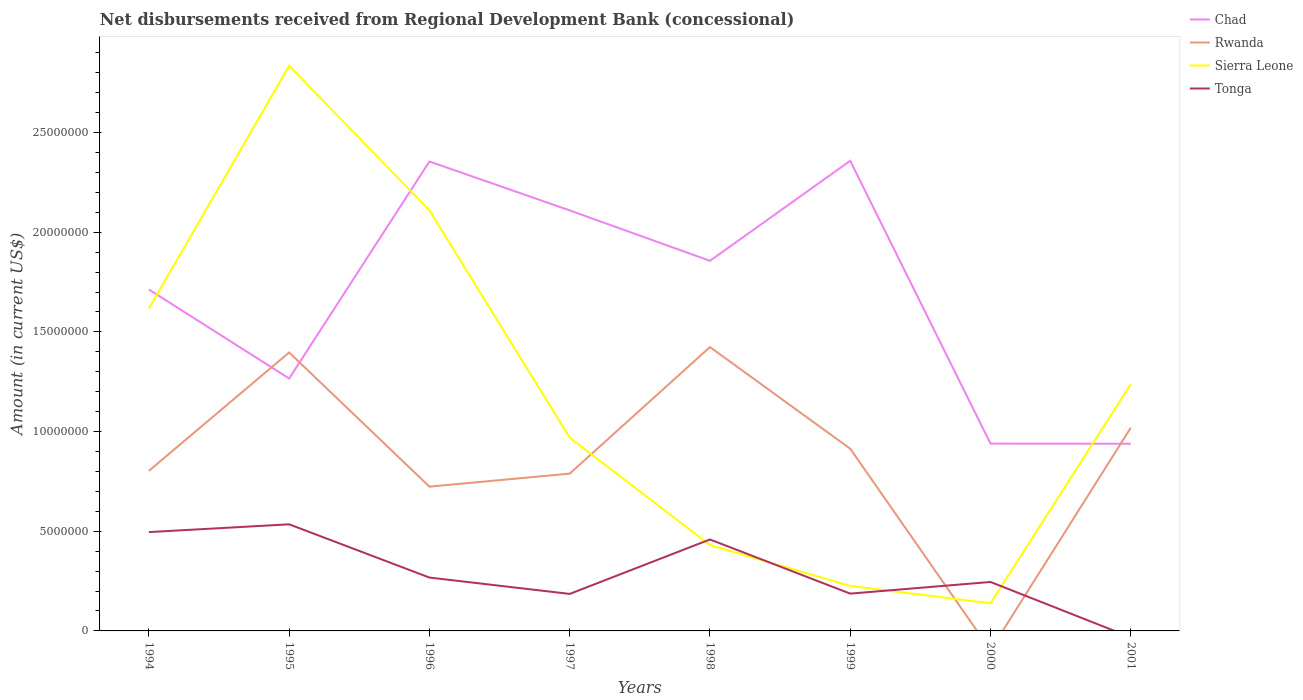How many different coloured lines are there?
Give a very brief answer. 4. What is the total amount of disbursements received from Regional Development Bank in Tonga in the graph?
Offer a very short reply. 2.13e+06. What is the difference between the highest and the second highest amount of disbursements received from Regional Development Bank in Chad?
Give a very brief answer. 1.42e+07. What is the difference between the highest and the lowest amount of disbursements received from Regional Development Bank in Sierra Leone?
Ensure brevity in your answer.  4. Is the amount of disbursements received from Regional Development Bank in Chad strictly greater than the amount of disbursements received from Regional Development Bank in Sierra Leone over the years?
Provide a succinct answer. No. How many lines are there?
Offer a terse response. 4. Does the graph contain any zero values?
Your answer should be compact. Yes. Where does the legend appear in the graph?
Ensure brevity in your answer.  Top right. How many legend labels are there?
Your answer should be compact. 4. What is the title of the graph?
Offer a very short reply. Net disbursements received from Regional Development Bank (concessional). What is the Amount (in current US$) in Chad in 1994?
Give a very brief answer. 1.71e+07. What is the Amount (in current US$) in Rwanda in 1994?
Your answer should be compact. 8.03e+06. What is the Amount (in current US$) in Sierra Leone in 1994?
Your answer should be very brief. 1.62e+07. What is the Amount (in current US$) in Tonga in 1994?
Offer a terse response. 4.96e+06. What is the Amount (in current US$) in Chad in 1995?
Give a very brief answer. 1.27e+07. What is the Amount (in current US$) of Rwanda in 1995?
Give a very brief answer. 1.40e+07. What is the Amount (in current US$) in Sierra Leone in 1995?
Give a very brief answer. 2.83e+07. What is the Amount (in current US$) in Tonga in 1995?
Offer a very short reply. 5.35e+06. What is the Amount (in current US$) in Chad in 1996?
Offer a very short reply. 2.35e+07. What is the Amount (in current US$) in Rwanda in 1996?
Your response must be concise. 7.24e+06. What is the Amount (in current US$) in Sierra Leone in 1996?
Your answer should be very brief. 2.11e+07. What is the Amount (in current US$) of Tonga in 1996?
Provide a short and direct response. 2.68e+06. What is the Amount (in current US$) in Chad in 1997?
Give a very brief answer. 2.11e+07. What is the Amount (in current US$) in Rwanda in 1997?
Provide a short and direct response. 7.89e+06. What is the Amount (in current US$) of Sierra Leone in 1997?
Your response must be concise. 9.70e+06. What is the Amount (in current US$) in Tonga in 1997?
Give a very brief answer. 1.86e+06. What is the Amount (in current US$) of Chad in 1998?
Give a very brief answer. 1.86e+07. What is the Amount (in current US$) of Rwanda in 1998?
Keep it short and to the point. 1.42e+07. What is the Amount (in current US$) of Sierra Leone in 1998?
Offer a terse response. 4.31e+06. What is the Amount (in current US$) of Tonga in 1998?
Your answer should be compact. 4.59e+06. What is the Amount (in current US$) in Chad in 1999?
Provide a short and direct response. 2.36e+07. What is the Amount (in current US$) in Rwanda in 1999?
Provide a short and direct response. 9.14e+06. What is the Amount (in current US$) of Sierra Leone in 1999?
Your response must be concise. 2.26e+06. What is the Amount (in current US$) in Tonga in 1999?
Ensure brevity in your answer.  1.87e+06. What is the Amount (in current US$) of Chad in 2000?
Provide a short and direct response. 9.40e+06. What is the Amount (in current US$) of Sierra Leone in 2000?
Your response must be concise. 1.39e+06. What is the Amount (in current US$) of Tonga in 2000?
Provide a short and direct response. 2.46e+06. What is the Amount (in current US$) in Chad in 2001?
Your answer should be compact. 9.39e+06. What is the Amount (in current US$) of Rwanda in 2001?
Your answer should be compact. 1.02e+07. What is the Amount (in current US$) of Sierra Leone in 2001?
Your answer should be compact. 1.24e+07. What is the Amount (in current US$) in Tonga in 2001?
Ensure brevity in your answer.  0. Across all years, what is the maximum Amount (in current US$) in Chad?
Provide a short and direct response. 2.36e+07. Across all years, what is the maximum Amount (in current US$) in Rwanda?
Your answer should be very brief. 1.42e+07. Across all years, what is the maximum Amount (in current US$) of Sierra Leone?
Offer a terse response. 2.83e+07. Across all years, what is the maximum Amount (in current US$) in Tonga?
Offer a very short reply. 5.35e+06. Across all years, what is the minimum Amount (in current US$) of Chad?
Give a very brief answer. 9.39e+06. Across all years, what is the minimum Amount (in current US$) in Rwanda?
Keep it short and to the point. 0. Across all years, what is the minimum Amount (in current US$) of Sierra Leone?
Make the answer very short. 1.39e+06. Across all years, what is the minimum Amount (in current US$) of Tonga?
Provide a short and direct response. 0. What is the total Amount (in current US$) in Chad in the graph?
Offer a terse response. 1.35e+08. What is the total Amount (in current US$) of Rwanda in the graph?
Give a very brief answer. 7.07e+07. What is the total Amount (in current US$) in Sierra Leone in the graph?
Offer a very short reply. 9.56e+07. What is the total Amount (in current US$) of Tonga in the graph?
Offer a very short reply. 2.38e+07. What is the difference between the Amount (in current US$) in Chad in 1994 and that in 1995?
Your response must be concise. 4.47e+06. What is the difference between the Amount (in current US$) of Rwanda in 1994 and that in 1995?
Give a very brief answer. -5.94e+06. What is the difference between the Amount (in current US$) in Sierra Leone in 1994 and that in 1995?
Ensure brevity in your answer.  -1.22e+07. What is the difference between the Amount (in current US$) of Tonga in 1994 and that in 1995?
Your response must be concise. -3.90e+05. What is the difference between the Amount (in current US$) of Chad in 1994 and that in 1996?
Your response must be concise. -6.42e+06. What is the difference between the Amount (in current US$) of Rwanda in 1994 and that in 1996?
Give a very brief answer. 7.94e+05. What is the difference between the Amount (in current US$) of Sierra Leone in 1994 and that in 1996?
Keep it short and to the point. -4.92e+06. What is the difference between the Amount (in current US$) in Tonga in 1994 and that in 1996?
Your answer should be compact. 2.28e+06. What is the difference between the Amount (in current US$) of Chad in 1994 and that in 1997?
Keep it short and to the point. -3.97e+06. What is the difference between the Amount (in current US$) in Rwanda in 1994 and that in 1997?
Your answer should be compact. 1.41e+05. What is the difference between the Amount (in current US$) of Sierra Leone in 1994 and that in 1997?
Offer a very short reply. 6.48e+06. What is the difference between the Amount (in current US$) of Tonga in 1994 and that in 1997?
Your answer should be compact. 3.10e+06. What is the difference between the Amount (in current US$) of Chad in 1994 and that in 1998?
Your answer should be compact. -1.44e+06. What is the difference between the Amount (in current US$) in Rwanda in 1994 and that in 1998?
Provide a short and direct response. -6.21e+06. What is the difference between the Amount (in current US$) in Sierra Leone in 1994 and that in 1998?
Keep it short and to the point. 1.19e+07. What is the difference between the Amount (in current US$) in Tonga in 1994 and that in 1998?
Ensure brevity in your answer.  3.70e+05. What is the difference between the Amount (in current US$) in Chad in 1994 and that in 1999?
Keep it short and to the point. -6.46e+06. What is the difference between the Amount (in current US$) in Rwanda in 1994 and that in 1999?
Your answer should be compact. -1.11e+06. What is the difference between the Amount (in current US$) of Sierra Leone in 1994 and that in 1999?
Your answer should be compact. 1.39e+07. What is the difference between the Amount (in current US$) in Tonga in 1994 and that in 1999?
Provide a succinct answer. 3.09e+06. What is the difference between the Amount (in current US$) of Chad in 1994 and that in 2000?
Provide a short and direct response. 7.73e+06. What is the difference between the Amount (in current US$) in Sierra Leone in 1994 and that in 2000?
Give a very brief answer. 1.48e+07. What is the difference between the Amount (in current US$) of Tonga in 1994 and that in 2000?
Provide a succinct answer. 2.50e+06. What is the difference between the Amount (in current US$) in Chad in 1994 and that in 2001?
Your response must be concise. 7.74e+06. What is the difference between the Amount (in current US$) in Rwanda in 1994 and that in 2001?
Your answer should be very brief. -2.16e+06. What is the difference between the Amount (in current US$) in Sierra Leone in 1994 and that in 2001?
Offer a very short reply. 3.80e+06. What is the difference between the Amount (in current US$) of Chad in 1995 and that in 1996?
Offer a terse response. -1.09e+07. What is the difference between the Amount (in current US$) of Rwanda in 1995 and that in 1996?
Keep it short and to the point. 6.73e+06. What is the difference between the Amount (in current US$) of Sierra Leone in 1995 and that in 1996?
Your answer should be compact. 7.25e+06. What is the difference between the Amount (in current US$) of Tonga in 1995 and that in 1996?
Your answer should be very brief. 2.67e+06. What is the difference between the Amount (in current US$) in Chad in 1995 and that in 1997?
Offer a terse response. -8.43e+06. What is the difference between the Amount (in current US$) in Rwanda in 1995 and that in 1997?
Ensure brevity in your answer.  6.08e+06. What is the difference between the Amount (in current US$) of Sierra Leone in 1995 and that in 1997?
Give a very brief answer. 1.87e+07. What is the difference between the Amount (in current US$) in Tonga in 1995 and that in 1997?
Your answer should be compact. 3.49e+06. What is the difference between the Amount (in current US$) in Chad in 1995 and that in 1998?
Make the answer very short. -5.90e+06. What is the difference between the Amount (in current US$) in Sierra Leone in 1995 and that in 1998?
Your answer should be very brief. 2.40e+07. What is the difference between the Amount (in current US$) of Tonga in 1995 and that in 1998?
Your answer should be compact. 7.60e+05. What is the difference between the Amount (in current US$) in Chad in 1995 and that in 1999?
Give a very brief answer. -1.09e+07. What is the difference between the Amount (in current US$) in Rwanda in 1995 and that in 1999?
Make the answer very short. 4.83e+06. What is the difference between the Amount (in current US$) of Sierra Leone in 1995 and that in 1999?
Give a very brief answer. 2.61e+07. What is the difference between the Amount (in current US$) in Tonga in 1995 and that in 1999?
Provide a succinct answer. 3.48e+06. What is the difference between the Amount (in current US$) of Chad in 1995 and that in 2000?
Offer a terse response. 3.26e+06. What is the difference between the Amount (in current US$) of Sierra Leone in 1995 and that in 2000?
Make the answer very short. 2.70e+07. What is the difference between the Amount (in current US$) of Tonga in 1995 and that in 2000?
Your answer should be compact. 2.89e+06. What is the difference between the Amount (in current US$) in Chad in 1995 and that in 2001?
Your answer should be compact. 3.27e+06. What is the difference between the Amount (in current US$) of Rwanda in 1995 and that in 2001?
Your response must be concise. 3.78e+06. What is the difference between the Amount (in current US$) of Sierra Leone in 1995 and that in 2001?
Your response must be concise. 1.60e+07. What is the difference between the Amount (in current US$) of Chad in 1996 and that in 1997?
Keep it short and to the point. 2.45e+06. What is the difference between the Amount (in current US$) in Rwanda in 1996 and that in 1997?
Provide a short and direct response. -6.53e+05. What is the difference between the Amount (in current US$) in Sierra Leone in 1996 and that in 1997?
Offer a terse response. 1.14e+07. What is the difference between the Amount (in current US$) of Tonga in 1996 and that in 1997?
Ensure brevity in your answer.  8.21e+05. What is the difference between the Amount (in current US$) of Chad in 1996 and that in 1998?
Provide a short and direct response. 4.98e+06. What is the difference between the Amount (in current US$) in Rwanda in 1996 and that in 1998?
Offer a very short reply. -7.00e+06. What is the difference between the Amount (in current US$) in Sierra Leone in 1996 and that in 1998?
Offer a terse response. 1.68e+07. What is the difference between the Amount (in current US$) in Tonga in 1996 and that in 1998?
Provide a short and direct response. -1.91e+06. What is the difference between the Amount (in current US$) in Chad in 1996 and that in 1999?
Make the answer very short. -3.50e+04. What is the difference between the Amount (in current US$) in Rwanda in 1996 and that in 1999?
Offer a terse response. -1.90e+06. What is the difference between the Amount (in current US$) of Sierra Leone in 1996 and that in 1999?
Make the answer very short. 1.88e+07. What is the difference between the Amount (in current US$) in Tonga in 1996 and that in 1999?
Your response must be concise. 8.06e+05. What is the difference between the Amount (in current US$) in Chad in 1996 and that in 2000?
Make the answer very short. 1.42e+07. What is the difference between the Amount (in current US$) in Sierra Leone in 1996 and that in 2000?
Ensure brevity in your answer.  1.97e+07. What is the difference between the Amount (in current US$) in Tonga in 1996 and that in 2000?
Ensure brevity in your answer.  2.21e+05. What is the difference between the Amount (in current US$) in Chad in 1996 and that in 2001?
Your answer should be very brief. 1.42e+07. What is the difference between the Amount (in current US$) in Rwanda in 1996 and that in 2001?
Your answer should be very brief. -2.95e+06. What is the difference between the Amount (in current US$) in Sierra Leone in 1996 and that in 2001?
Provide a short and direct response. 8.72e+06. What is the difference between the Amount (in current US$) of Chad in 1997 and that in 1998?
Your response must be concise. 2.53e+06. What is the difference between the Amount (in current US$) of Rwanda in 1997 and that in 1998?
Make the answer very short. -6.35e+06. What is the difference between the Amount (in current US$) of Sierra Leone in 1997 and that in 1998?
Make the answer very short. 5.39e+06. What is the difference between the Amount (in current US$) of Tonga in 1997 and that in 1998?
Provide a succinct answer. -2.73e+06. What is the difference between the Amount (in current US$) of Chad in 1997 and that in 1999?
Keep it short and to the point. -2.49e+06. What is the difference between the Amount (in current US$) in Rwanda in 1997 and that in 1999?
Your response must be concise. -1.25e+06. What is the difference between the Amount (in current US$) in Sierra Leone in 1997 and that in 1999?
Provide a succinct answer. 7.44e+06. What is the difference between the Amount (in current US$) of Tonga in 1997 and that in 1999?
Provide a succinct answer. -1.50e+04. What is the difference between the Amount (in current US$) in Chad in 1997 and that in 2000?
Give a very brief answer. 1.17e+07. What is the difference between the Amount (in current US$) in Sierra Leone in 1997 and that in 2000?
Give a very brief answer. 8.31e+06. What is the difference between the Amount (in current US$) in Tonga in 1997 and that in 2000?
Give a very brief answer. -6.00e+05. What is the difference between the Amount (in current US$) of Chad in 1997 and that in 2001?
Provide a succinct answer. 1.17e+07. What is the difference between the Amount (in current US$) of Rwanda in 1997 and that in 2001?
Provide a succinct answer. -2.30e+06. What is the difference between the Amount (in current US$) in Sierra Leone in 1997 and that in 2001?
Your answer should be very brief. -2.68e+06. What is the difference between the Amount (in current US$) of Chad in 1998 and that in 1999?
Ensure brevity in your answer.  -5.02e+06. What is the difference between the Amount (in current US$) in Rwanda in 1998 and that in 1999?
Your answer should be compact. 5.10e+06. What is the difference between the Amount (in current US$) in Sierra Leone in 1998 and that in 1999?
Offer a very short reply. 2.05e+06. What is the difference between the Amount (in current US$) of Tonga in 1998 and that in 1999?
Make the answer very short. 2.72e+06. What is the difference between the Amount (in current US$) of Chad in 1998 and that in 2000?
Provide a short and direct response. 9.17e+06. What is the difference between the Amount (in current US$) of Sierra Leone in 1998 and that in 2000?
Make the answer very short. 2.92e+06. What is the difference between the Amount (in current US$) in Tonga in 1998 and that in 2000?
Ensure brevity in your answer.  2.13e+06. What is the difference between the Amount (in current US$) of Chad in 1998 and that in 2001?
Your response must be concise. 9.18e+06. What is the difference between the Amount (in current US$) in Rwanda in 1998 and that in 2001?
Make the answer very short. 4.05e+06. What is the difference between the Amount (in current US$) of Sierra Leone in 1998 and that in 2001?
Provide a short and direct response. -8.07e+06. What is the difference between the Amount (in current US$) of Chad in 1999 and that in 2000?
Provide a short and direct response. 1.42e+07. What is the difference between the Amount (in current US$) of Sierra Leone in 1999 and that in 2000?
Give a very brief answer. 8.71e+05. What is the difference between the Amount (in current US$) of Tonga in 1999 and that in 2000?
Offer a very short reply. -5.85e+05. What is the difference between the Amount (in current US$) of Chad in 1999 and that in 2001?
Your answer should be very brief. 1.42e+07. What is the difference between the Amount (in current US$) in Rwanda in 1999 and that in 2001?
Provide a succinct answer. -1.05e+06. What is the difference between the Amount (in current US$) of Sierra Leone in 1999 and that in 2001?
Make the answer very short. -1.01e+07. What is the difference between the Amount (in current US$) in Chad in 2000 and that in 2001?
Your answer should be compact. 8000. What is the difference between the Amount (in current US$) of Sierra Leone in 2000 and that in 2001?
Offer a terse response. -1.10e+07. What is the difference between the Amount (in current US$) in Chad in 1994 and the Amount (in current US$) in Rwanda in 1995?
Your response must be concise. 3.16e+06. What is the difference between the Amount (in current US$) of Chad in 1994 and the Amount (in current US$) of Sierra Leone in 1995?
Offer a terse response. -1.12e+07. What is the difference between the Amount (in current US$) in Chad in 1994 and the Amount (in current US$) in Tonga in 1995?
Ensure brevity in your answer.  1.18e+07. What is the difference between the Amount (in current US$) in Rwanda in 1994 and the Amount (in current US$) in Sierra Leone in 1995?
Offer a very short reply. -2.03e+07. What is the difference between the Amount (in current US$) of Rwanda in 1994 and the Amount (in current US$) of Tonga in 1995?
Offer a terse response. 2.68e+06. What is the difference between the Amount (in current US$) in Sierra Leone in 1994 and the Amount (in current US$) in Tonga in 1995?
Keep it short and to the point. 1.08e+07. What is the difference between the Amount (in current US$) in Chad in 1994 and the Amount (in current US$) in Rwanda in 1996?
Ensure brevity in your answer.  9.89e+06. What is the difference between the Amount (in current US$) in Chad in 1994 and the Amount (in current US$) in Sierra Leone in 1996?
Offer a very short reply. -3.97e+06. What is the difference between the Amount (in current US$) of Chad in 1994 and the Amount (in current US$) of Tonga in 1996?
Keep it short and to the point. 1.44e+07. What is the difference between the Amount (in current US$) of Rwanda in 1994 and the Amount (in current US$) of Sierra Leone in 1996?
Offer a terse response. -1.31e+07. What is the difference between the Amount (in current US$) in Rwanda in 1994 and the Amount (in current US$) in Tonga in 1996?
Provide a succinct answer. 5.35e+06. What is the difference between the Amount (in current US$) of Sierra Leone in 1994 and the Amount (in current US$) of Tonga in 1996?
Provide a succinct answer. 1.35e+07. What is the difference between the Amount (in current US$) of Chad in 1994 and the Amount (in current US$) of Rwanda in 1997?
Give a very brief answer. 9.24e+06. What is the difference between the Amount (in current US$) of Chad in 1994 and the Amount (in current US$) of Sierra Leone in 1997?
Provide a short and direct response. 7.43e+06. What is the difference between the Amount (in current US$) of Chad in 1994 and the Amount (in current US$) of Tonga in 1997?
Offer a terse response. 1.53e+07. What is the difference between the Amount (in current US$) in Rwanda in 1994 and the Amount (in current US$) in Sierra Leone in 1997?
Ensure brevity in your answer.  -1.66e+06. What is the difference between the Amount (in current US$) of Rwanda in 1994 and the Amount (in current US$) of Tonga in 1997?
Offer a terse response. 6.18e+06. What is the difference between the Amount (in current US$) in Sierra Leone in 1994 and the Amount (in current US$) in Tonga in 1997?
Ensure brevity in your answer.  1.43e+07. What is the difference between the Amount (in current US$) of Chad in 1994 and the Amount (in current US$) of Rwanda in 1998?
Provide a short and direct response. 2.89e+06. What is the difference between the Amount (in current US$) of Chad in 1994 and the Amount (in current US$) of Sierra Leone in 1998?
Your answer should be compact. 1.28e+07. What is the difference between the Amount (in current US$) in Chad in 1994 and the Amount (in current US$) in Tonga in 1998?
Offer a terse response. 1.25e+07. What is the difference between the Amount (in current US$) of Rwanda in 1994 and the Amount (in current US$) of Sierra Leone in 1998?
Your answer should be very brief. 3.72e+06. What is the difference between the Amount (in current US$) of Rwanda in 1994 and the Amount (in current US$) of Tonga in 1998?
Provide a short and direct response. 3.44e+06. What is the difference between the Amount (in current US$) of Sierra Leone in 1994 and the Amount (in current US$) of Tonga in 1998?
Offer a very short reply. 1.16e+07. What is the difference between the Amount (in current US$) of Chad in 1994 and the Amount (in current US$) of Rwanda in 1999?
Make the answer very short. 7.99e+06. What is the difference between the Amount (in current US$) of Chad in 1994 and the Amount (in current US$) of Sierra Leone in 1999?
Offer a terse response. 1.49e+07. What is the difference between the Amount (in current US$) in Chad in 1994 and the Amount (in current US$) in Tonga in 1999?
Offer a terse response. 1.53e+07. What is the difference between the Amount (in current US$) of Rwanda in 1994 and the Amount (in current US$) of Sierra Leone in 1999?
Keep it short and to the point. 5.77e+06. What is the difference between the Amount (in current US$) of Rwanda in 1994 and the Amount (in current US$) of Tonga in 1999?
Keep it short and to the point. 6.16e+06. What is the difference between the Amount (in current US$) in Sierra Leone in 1994 and the Amount (in current US$) in Tonga in 1999?
Your response must be concise. 1.43e+07. What is the difference between the Amount (in current US$) of Chad in 1994 and the Amount (in current US$) of Sierra Leone in 2000?
Offer a very short reply. 1.57e+07. What is the difference between the Amount (in current US$) in Chad in 1994 and the Amount (in current US$) in Tonga in 2000?
Provide a succinct answer. 1.47e+07. What is the difference between the Amount (in current US$) of Rwanda in 1994 and the Amount (in current US$) of Sierra Leone in 2000?
Offer a terse response. 6.64e+06. What is the difference between the Amount (in current US$) in Rwanda in 1994 and the Amount (in current US$) in Tonga in 2000?
Make the answer very short. 5.58e+06. What is the difference between the Amount (in current US$) of Sierra Leone in 1994 and the Amount (in current US$) of Tonga in 2000?
Your answer should be very brief. 1.37e+07. What is the difference between the Amount (in current US$) of Chad in 1994 and the Amount (in current US$) of Rwanda in 2001?
Make the answer very short. 6.94e+06. What is the difference between the Amount (in current US$) of Chad in 1994 and the Amount (in current US$) of Sierra Leone in 2001?
Give a very brief answer. 4.75e+06. What is the difference between the Amount (in current US$) in Rwanda in 1994 and the Amount (in current US$) in Sierra Leone in 2001?
Provide a succinct answer. -4.34e+06. What is the difference between the Amount (in current US$) of Chad in 1995 and the Amount (in current US$) of Rwanda in 1996?
Your response must be concise. 5.42e+06. What is the difference between the Amount (in current US$) in Chad in 1995 and the Amount (in current US$) in Sierra Leone in 1996?
Provide a succinct answer. -8.44e+06. What is the difference between the Amount (in current US$) in Chad in 1995 and the Amount (in current US$) in Tonga in 1996?
Provide a succinct answer. 9.98e+06. What is the difference between the Amount (in current US$) in Rwanda in 1995 and the Amount (in current US$) in Sierra Leone in 1996?
Give a very brief answer. -7.13e+06. What is the difference between the Amount (in current US$) of Rwanda in 1995 and the Amount (in current US$) of Tonga in 1996?
Ensure brevity in your answer.  1.13e+07. What is the difference between the Amount (in current US$) of Sierra Leone in 1995 and the Amount (in current US$) of Tonga in 1996?
Keep it short and to the point. 2.57e+07. What is the difference between the Amount (in current US$) of Chad in 1995 and the Amount (in current US$) of Rwanda in 1997?
Keep it short and to the point. 4.77e+06. What is the difference between the Amount (in current US$) in Chad in 1995 and the Amount (in current US$) in Sierra Leone in 1997?
Give a very brief answer. 2.97e+06. What is the difference between the Amount (in current US$) of Chad in 1995 and the Amount (in current US$) of Tonga in 1997?
Give a very brief answer. 1.08e+07. What is the difference between the Amount (in current US$) of Rwanda in 1995 and the Amount (in current US$) of Sierra Leone in 1997?
Your response must be concise. 4.27e+06. What is the difference between the Amount (in current US$) in Rwanda in 1995 and the Amount (in current US$) in Tonga in 1997?
Offer a very short reply. 1.21e+07. What is the difference between the Amount (in current US$) in Sierra Leone in 1995 and the Amount (in current US$) in Tonga in 1997?
Offer a very short reply. 2.65e+07. What is the difference between the Amount (in current US$) in Chad in 1995 and the Amount (in current US$) in Rwanda in 1998?
Offer a very short reply. -1.58e+06. What is the difference between the Amount (in current US$) in Chad in 1995 and the Amount (in current US$) in Sierra Leone in 1998?
Keep it short and to the point. 8.36e+06. What is the difference between the Amount (in current US$) of Chad in 1995 and the Amount (in current US$) of Tonga in 1998?
Offer a very short reply. 8.07e+06. What is the difference between the Amount (in current US$) in Rwanda in 1995 and the Amount (in current US$) in Sierra Leone in 1998?
Your answer should be very brief. 9.66e+06. What is the difference between the Amount (in current US$) of Rwanda in 1995 and the Amount (in current US$) of Tonga in 1998?
Your response must be concise. 9.38e+06. What is the difference between the Amount (in current US$) of Sierra Leone in 1995 and the Amount (in current US$) of Tonga in 1998?
Your answer should be compact. 2.38e+07. What is the difference between the Amount (in current US$) of Chad in 1995 and the Amount (in current US$) of Rwanda in 1999?
Keep it short and to the point. 3.52e+06. What is the difference between the Amount (in current US$) of Chad in 1995 and the Amount (in current US$) of Sierra Leone in 1999?
Offer a very short reply. 1.04e+07. What is the difference between the Amount (in current US$) of Chad in 1995 and the Amount (in current US$) of Tonga in 1999?
Your answer should be very brief. 1.08e+07. What is the difference between the Amount (in current US$) of Rwanda in 1995 and the Amount (in current US$) of Sierra Leone in 1999?
Give a very brief answer. 1.17e+07. What is the difference between the Amount (in current US$) of Rwanda in 1995 and the Amount (in current US$) of Tonga in 1999?
Your response must be concise. 1.21e+07. What is the difference between the Amount (in current US$) of Sierra Leone in 1995 and the Amount (in current US$) of Tonga in 1999?
Your answer should be compact. 2.65e+07. What is the difference between the Amount (in current US$) of Chad in 1995 and the Amount (in current US$) of Sierra Leone in 2000?
Offer a terse response. 1.13e+07. What is the difference between the Amount (in current US$) of Chad in 1995 and the Amount (in current US$) of Tonga in 2000?
Offer a very short reply. 1.02e+07. What is the difference between the Amount (in current US$) of Rwanda in 1995 and the Amount (in current US$) of Sierra Leone in 2000?
Your answer should be compact. 1.26e+07. What is the difference between the Amount (in current US$) in Rwanda in 1995 and the Amount (in current US$) in Tonga in 2000?
Your answer should be compact. 1.15e+07. What is the difference between the Amount (in current US$) in Sierra Leone in 1995 and the Amount (in current US$) in Tonga in 2000?
Your response must be concise. 2.59e+07. What is the difference between the Amount (in current US$) in Chad in 1995 and the Amount (in current US$) in Rwanda in 2001?
Offer a terse response. 2.47e+06. What is the difference between the Amount (in current US$) of Chad in 1995 and the Amount (in current US$) of Sierra Leone in 2001?
Your answer should be compact. 2.86e+05. What is the difference between the Amount (in current US$) in Rwanda in 1995 and the Amount (in current US$) in Sierra Leone in 2001?
Your answer should be very brief. 1.59e+06. What is the difference between the Amount (in current US$) in Chad in 1996 and the Amount (in current US$) in Rwanda in 1997?
Offer a terse response. 1.57e+07. What is the difference between the Amount (in current US$) of Chad in 1996 and the Amount (in current US$) of Sierra Leone in 1997?
Provide a short and direct response. 1.39e+07. What is the difference between the Amount (in current US$) in Chad in 1996 and the Amount (in current US$) in Tonga in 1997?
Ensure brevity in your answer.  2.17e+07. What is the difference between the Amount (in current US$) in Rwanda in 1996 and the Amount (in current US$) in Sierra Leone in 1997?
Offer a terse response. -2.46e+06. What is the difference between the Amount (in current US$) of Rwanda in 1996 and the Amount (in current US$) of Tonga in 1997?
Your answer should be very brief. 5.38e+06. What is the difference between the Amount (in current US$) of Sierra Leone in 1996 and the Amount (in current US$) of Tonga in 1997?
Keep it short and to the point. 1.92e+07. What is the difference between the Amount (in current US$) of Chad in 1996 and the Amount (in current US$) of Rwanda in 1998?
Offer a very short reply. 9.31e+06. What is the difference between the Amount (in current US$) of Chad in 1996 and the Amount (in current US$) of Sierra Leone in 1998?
Keep it short and to the point. 1.92e+07. What is the difference between the Amount (in current US$) in Chad in 1996 and the Amount (in current US$) in Tonga in 1998?
Provide a short and direct response. 1.90e+07. What is the difference between the Amount (in current US$) of Rwanda in 1996 and the Amount (in current US$) of Sierra Leone in 1998?
Your response must be concise. 2.93e+06. What is the difference between the Amount (in current US$) in Rwanda in 1996 and the Amount (in current US$) in Tonga in 1998?
Your answer should be very brief. 2.65e+06. What is the difference between the Amount (in current US$) of Sierra Leone in 1996 and the Amount (in current US$) of Tonga in 1998?
Ensure brevity in your answer.  1.65e+07. What is the difference between the Amount (in current US$) in Chad in 1996 and the Amount (in current US$) in Rwanda in 1999?
Your response must be concise. 1.44e+07. What is the difference between the Amount (in current US$) in Chad in 1996 and the Amount (in current US$) in Sierra Leone in 1999?
Your answer should be compact. 2.13e+07. What is the difference between the Amount (in current US$) of Chad in 1996 and the Amount (in current US$) of Tonga in 1999?
Your response must be concise. 2.17e+07. What is the difference between the Amount (in current US$) of Rwanda in 1996 and the Amount (in current US$) of Sierra Leone in 1999?
Give a very brief answer. 4.98e+06. What is the difference between the Amount (in current US$) of Rwanda in 1996 and the Amount (in current US$) of Tonga in 1999?
Your answer should be compact. 5.37e+06. What is the difference between the Amount (in current US$) in Sierra Leone in 1996 and the Amount (in current US$) in Tonga in 1999?
Offer a terse response. 1.92e+07. What is the difference between the Amount (in current US$) of Chad in 1996 and the Amount (in current US$) of Sierra Leone in 2000?
Offer a terse response. 2.22e+07. What is the difference between the Amount (in current US$) in Chad in 1996 and the Amount (in current US$) in Tonga in 2000?
Offer a very short reply. 2.11e+07. What is the difference between the Amount (in current US$) in Rwanda in 1996 and the Amount (in current US$) in Sierra Leone in 2000?
Ensure brevity in your answer.  5.85e+06. What is the difference between the Amount (in current US$) in Rwanda in 1996 and the Amount (in current US$) in Tonga in 2000?
Provide a short and direct response. 4.78e+06. What is the difference between the Amount (in current US$) of Sierra Leone in 1996 and the Amount (in current US$) of Tonga in 2000?
Offer a very short reply. 1.86e+07. What is the difference between the Amount (in current US$) of Chad in 1996 and the Amount (in current US$) of Rwanda in 2001?
Your answer should be compact. 1.34e+07. What is the difference between the Amount (in current US$) of Chad in 1996 and the Amount (in current US$) of Sierra Leone in 2001?
Your answer should be very brief. 1.12e+07. What is the difference between the Amount (in current US$) in Rwanda in 1996 and the Amount (in current US$) in Sierra Leone in 2001?
Provide a short and direct response. -5.14e+06. What is the difference between the Amount (in current US$) in Chad in 1997 and the Amount (in current US$) in Rwanda in 1998?
Give a very brief answer. 6.86e+06. What is the difference between the Amount (in current US$) in Chad in 1997 and the Amount (in current US$) in Sierra Leone in 1998?
Make the answer very short. 1.68e+07. What is the difference between the Amount (in current US$) in Chad in 1997 and the Amount (in current US$) in Tonga in 1998?
Provide a succinct answer. 1.65e+07. What is the difference between the Amount (in current US$) of Rwanda in 1997 and the Amount (in current US$) of Sierra Leone in 1998?
Your answer should be compact. 3.58e+06. What is the difference between the Amount (in current US$) in Rwanda in 1997 and the Amount (in current US$) in Tonga in 1998?
Your answer should be compact. 3.30e+06. What is the difference between the Amount (in current US$) in Sierra Leone in 1997 and the Amount (in current US$) in Tonga in 1998?
Ensure brevity in your answer.  5.11e+06. What is the difference between the Amount (in current US$) of Chad in 1997 and the Amount (in current US$) of Rwanda in 1999?
Keep it short and to the point. 1.20e+07. What is the difference between the Amount (in current US$) in Chad in 1997 and the Amount (in current US$) in Sierra Leone in 1999?
Your response must be concise. 1.88e+07. What is the difference between the Amount (in current US$) in Chad in 1997 and the Amount (in current US$) in Tonga in 1999?
Ensure brevity in your answer.  1.92e+07. What is the difference between the Amount (in current US$) in Rwanda in 1997 and the Amount (in current US$) in Sierra Leone in 1999?
Give a very brief answer. 5.63e+06. What is the difference between the Amount (in current US$) in Rwanda in 1997 and the Amount (in current US$) in Tonga in 1999?
Your answer should be compact. 6.02e+06. What is the difference between the Amount (in current US$) in Sierra Leone in 1997 and the Amount (in current US$) in Tonga in 1999?
Provide a short and direct response. 7.82e+06. What is the difference between the Amount (in current US$) in Chad in 1997 and the Amount (in current US$) in Sierra Leone in 2000?
Make the answer very short. 1.97e+07. What is the difference between the Amount (in current US$) in Chad in 1997 and the Amount (in current US$) in Tonga in 2000?
Keep it short and to the point. 1.86e+07. What is the difference between the Amount (in current US$) in Rwanda in 1997 and the Amount (in current US$) in Sierra Leone in 2000?
Ensure brevity in your answer.  6.50e+06. What is the difference between the Amount (in current US$) of Rwanda in 1997 and the Amount (in current US$) of Tonga in 2000?
Offer a very short reply. 5.43e+06. What is the difference between the Amount (in current US$) of Sierra Leone in 1997 and the Amount (in current US$) of Tonga in 2000?
Your answer should be compact. 7.24e+06. What is the difference between the Amount (in current US$) of Chad in 1997 and the Amount (in current US$) of Rwanda in 2001?
Offer a very short reply. 1.09e+07. What is the difference between the Amount (in current US$) of Chad in 1997 and the Amount (in current US$) of Sierra Leone in 2001?
Make the answer very short. 8.72e+06. What is the difference between the Amount (in current US$) of Rwanda in 1997 and the Amount (in current US$) of Sierra Leone in 2001?
Your answer should be compact. -4.48e+06. What is the difference between the Amount (in current US$) in Chad in 1998 and the Amount (in current US$) in Rwanda in 1999?
Ensure brevity in your answer.  9.42e+06. What is the difference between the Amount (in current US$) of Chad in 1998 and the Amount (in current US$) of Sierra Leone in 1999?
Make the answer very short. 1.63e+07. What is the difference between the Amount (in current US$) of Chad in 1998 and the Amount (in current US$) of Tonga in 1999?
Provide a succinct answer. 1.67e+07. What is the difference between the Amount (in current US$) of Rwanda in 1998 and the Amount (in current US$) of Sierra Leone in 1999?
Ensure brevity in your answer.  1.20e+07. What is the difference between the Amount (in current US$) in Rwanda in 1998 and the Amount (in current US$) in Tonga in 1999?
Your answer should be compact. 1.24e+07. What is the difference between the Amount (in current US$) in Sierra Leone in 1998 and the Amount (in current US$) in Tonga in 1999?
Your response must be concise. 2.44e+06. What is the difference between the Amount (in current US$) of Chad in 1998 and the Amount (in current US$) of Sierra Leone in 2000?
Offer a terse response. 1.72e+07. What is the difference between the Amount (in current US$) of Chad in 1998 and the Amount (in current US$) of Tonga in 2000?
Your answer should be compact. 1.61e+07. What is the difference between the Amount (in current US$) of Rwanda in 1998 and the Amount (in current US$) of Sierra Leone in 2000?
Provide a short and direct response. 1.29e+07. What is the difference between the Amount (in current US$) of Rwanda in 1998 and the Amount (in current US$) of Tonga in 2000?
Give a very brief answer. 1.18e+07. What is the difference between the Amount (in current US$) of Sierra Leone in 1998 and the Amount (in current US$) of Tonga in 2000?
Provide a short and direct response. 1.85e+06. What is the difference between the Amount (in current US$) in Chad in 1998 and the Amount (in current US$) in Rwanda in 2001?
Your answer should be very brief. 8.38e+06. What is the difference between the Amount (in current US$) in Chad in 1998 and the Amount (in current US$) in Sierra Leone in 2001?
Provide a short and direct response. 6.19e+06. What is the difference between the Amount (in current US$) in Rwanda in 1998 and the Amount (in current US$) in Sierra Leone in 2001?
Offer a terse response. 1.86e+06. What is the difference between the Amount (in current US$) of Chad in 1999 and the Amount (in current US$) of Sierra Leone in 2000?
Make the answer very short. 2.22e+07. What is the difference between the Amount (in current US$) of Chad in 1999 and the Amount (in current US$) of Tonga in 2000?
Provide a short and direct response. 2.11e+07. What is the difference between the Amount (in current US$) in Rwanda in 1999 and the Amount (in current US$) in Sierra Leone in 2000?
Your response must be concise. 7.75e+06. What is the difference between the Amount (in current US$) in Rwanda in 1999 and the Amount (in current US$) in Tonga in 2000?
Your response must be concise. 6.68e+06. What is the difference between the Amount (in current US$) of Sierra Leone in 1999 and the Amount (in current US$) of Tonga in 2000?
Keep it short and to the point. -1.98e+05. What is the difference between the Amount (in current US$) in Chad in 1999 and the Amount (in current US$) in Rwanda in 2001?
Make the answer very short. 1.34e+07. What is the difference between the Amount (in current US$) of Chad in 1999 and the Amount (in current US$) of Sierra Leone in 2001?
Make the answer very short. 1.12e+07. What is the difference between the Amount (in current US$) in Rwanda in 1999 and the Amount (in current US$) in Sierra Leone in 2001?
Your answer should be very brief. -3.23e+06. What is the difference between the Amount (in current US$) in Chad in 2000 and the Amount (in current US$) in Rwanda in 2001?
Give a very brief answer. -7.93e+05. What is the difference between the Amount (in current US$) in Chad in 2000 and the Amount (in current US$) in Sierra Leone in 2001?
Keep it short and to the point. -2.98e+06. What is the average Amount (in current US$) in Chad per year?
Offer a very short reply. 1.69e+07. What is the average Amount (in current US$) of Rwanda per year?
Your answer should be very brief. 8.84e+06. What is the average Amount (in current US$) in Sierra Leone per year?
Give a very brief answer. 1.20e+07. What is the average Amount (in current US$) of Tonga per year?
Offer a very short reply. 2.97e+06. In the year 1994, what is the difference between the Amount (in current US$) of Chad and Amount (in current US$) of Rwanda?
Your answer should be compact. 9.10e+06. In the year 1994, what is the difference between the Amount (in current US$) in Chad and Amount (in current US$) in Sierra Leone?
Provide a succinct answer. 9.53e+05. In the year 1994, what is the difference between the Amount (in current US$) in Chad and Amount (in current US$) in Tonga?
Keep it short and to the point. 1.22e+07. In the year 1994, what is the difference between the Amount (in current US$) of Rwanda and Amount (in current US$) of Sierra Leone?
Provide a short and direct response. -8.14e+06. In the year 1994, what is the difference between the Amount (in current US$) in Rwanda and Amount (in current US$) in Tonga?
Ensure brevity in your answer.  3.07e+06. In the year 1994, what is the difference between the Amount (in current US$) in Sierra Leone and Amount (in current US$) in Tonga?
Your response must be concise. 1.12e+07. In the year 1995, what is the difference between the Amount (in current US$) in Chad and Amount (in current US$) in Rwanda?
Give a very brief answer. -1.31e+06. In the year 1995, what is the difference between the Amount (in current US$) of Chad and Amount (in current US$) of Sierra Leone?
Your response must be concise. -1.57e+07. In the year 1995, what is the difference between the Amount (in current US$) in Chad and Amount (in current US$) in Tonga?
Ensure brevity in your answer.  7.31e+06. In the year 1995, what is the difference between the Amount (in current US$) in Rwanda and Amount (in current US$) in Sierra Leone?
Your answer should be very brief. -1.44e+07. In the year 1995, what is the difference between the Amount (in current US$) of Rwanda and Amount (in current US$) of Tonga?
Ensure brevity in your answer.  8.62e+06. In the year 1995, what is the difference between the Amount (in current US$) of Sierra Leone and Amount (in current US$) of Tonga?
Provide a succinct answer. 2.30e+07. In the year 1996, what is the difference between the Amount (in current US$) in Chad and Amount (in current US$) in Rwanda?
Your answer should be compact. 1.63e+07. In the year 1996, what is the difference between the Amount (in current US$) of Chad and Amount (in current US$) of Sierra Leone?
Ensure brevity in your answer.  2.45e+06. In the year 1996, what is the difference between the Amount (in current US$) of Chad and Amount (in current US$) of Tonga?
Offer a terse response. 2.09e+07. In the year 1996, what is the difference between the Amount (in current US$) in Rwanda and Amount (in current US$) in Sierra Leone?
Offer a terse response. -1.39e+07. In the year 1996, what is the difference between the Amount (in current US$) in Rwanda and Amount (in current US$) in Tonga?
Your answer should be compact. 4.56e+06. In the year 1996, what is the difference between the Amount (in current US$) in Sierra Leone and Amount (in current US$) in Tonga?
Your answer should be compact. 1.84e+07. In the year 1997, what is the difference between the Amount (in current US$) in Chad and Amount (in current US$) in Rwanda?
Provide a succinct answer. 1.32e+07. In the year 1997, what is the difference between the Amount (in current US$) of Chad and Amount (in current US$) of Sierra Leone?
Your answer should be very brief. 1.14e+07. In the year 1997, what is the difference between the Amount (in current US$) in Chad and Amount (in current US$) in Tonga?
Provide a short and direct response. 1.92e+07. In the year 1997, what is the difference between the Amount (in current US$) of Rwanda and Amount (in current US$) of Sierra Leone?
Offer a very short reply. -1.80e+06. In the year 1997, what is the difference between the Amount (in current US$) of Rwanda and Amount (in current US$) of Tonga?
Provide a short and direct response. 6.03e+06. In the year 1997, what is the difference between the Amount (in current US$) of Sierra Leone and Amount (in current US$) of Tonga?
Provide a succinct answer. 7.84e+06. In the year 1998, what is the difference between the Amount (in current US$) in Chad and Amount (in current US$) in Rwanda?
Ensure brevity in your answer.  4.33e+06. In the year 1998, what is the difference between the Amount (in current US$) of Chad and Amount (in current US$) of Sierra Leone?
Give a very brief answer. 1.43e+07. In the year 1998, what is the difference between the Amount (in current US$) in Chad and Amount (in current US$) in Tonga?
Provide a succinct answer. 1.40e+07. In the year 1998, what is the difference between the Amount (in current US$) in Rwanda and Amount (in current US$) in Sierra Leone?
Offer a terse response. 9.93e+06. In the year 1998, what is the difference between the Amount (in current US$) of Rwanda and Amount (in current US$) of Tonga?
Provide a succinct answer. 9.65e+06. In the year 1998, what is the difference between the Amount (in current US$) in Sierra Leone and Amount (in current US$) in Tonga?
Provide a short and direct response. -2.82e+05. In the year 1999, what is the difference between the Amount (in current US$) in Chad and Amount (in current US$) in Rwanda?
Offer a terse response. 1.44e+07. In the year 1999, what is the difference between the Amount (in current US$) of Chad and Amount (in current US$) of Sierra Leone?
Your response must be concise. 2.13e+07. In the year 1999, what is the difference between the Amount (in current US$) in Chad and Amount (in current US$) in Tonga?
Keep it short and to the point. 2.17e+07. In the year 1999, what is the difference between the Amount (in current US$) in Rwanda and Amount (in current US$) in Sierra Leone?
Your response must be concise. 6.88e+06. In the year 1999, what is the difference between the Amount (in current US$) of Rwanda and Amount (in current US$) of Tonga?
Keep it short and to the point. 7.27e+06. In the year 1999, what is the difference between the Amount (in current US$) of Sierra Leone and Amount (in current US$) of Tonga?
Your response must be concise. 3.87e+05. In the year 2000, what is the difference between the Amount (in current US$) of Chad and Amount (in current US$) of Sierra Leone?
Your response must be concise. 8.01e+06. In the year 2000, what is the difference between the Amount (in current US$) in Chad and Amount (in current US$) in Tonga?
Keep it short and to the point. 6.94e+06. In the year 2000, what is the difference between the Amount (in current US$) of Sierra Leone and Amount (in current US$) of Tonga?
Offer a terse response. -1.07e+06. In the year 2001, what is the difference between the Amount (in current US$) of Chad and Amount (in current US$) of Rwanda?
Your response must be concise. -8.01e+05. In the year 2001, what is the difference between the Amount (in current US$) in Chad and Amount (in current US$) in Sierra Leone?
Make the answer very short. -2.99e+06. In the year 2001, what is the difference between the Amount (in current US$) of Rwanda and Amount (in current US$) of Sierra Leone?
Offer a very short reply. -2.18e+06. What is the ratio of the Amount (in current US$) of Chad in 1994 to that in 1995?
Your answer should be very brief. 1.35. What is the ratio of the Amount (in current US$) in Rwanda in 1994 to that in 1995?
Your response must be concise. 0.57. What is the ratio of the Amount (in current US$) in Sierra Leone in 1994 to that in 1995?
Your answer should be very brief. 0.57. What is the ratio of the Amount (in current US$) in Tonga in 1994 to that in 1995?
Your answer should be very brief. 0.93. What is the ratio of the Amount (in current US$) in Chad in 1994 to that in 1996?
Provide a short and direct response. 0.73. What is the ratio of the Amount (in current US$) in Rwanda in 1994 to that in 1996?
Offer a very short reply. 1.11. What is the ratio of the Amount (in current US$) in Sierra Leone in 1994 to that in 1996?
Ensure brevity in your answer.  0.77. What is the ratio of the Amount (in current US$) of Tonga in 1994 to that in 1996?
Ensure brevity in your answer.  1.85. What is the ratio of the Amount (in current US$) in Chad in 1994 to that in 1997?
Make the answer very short. 0.81. What is the ratio of the Amount (in current US$) in Rwanda in 1994 to that in 1997?
Your answer should be very brief. 1.02. What is the ratio of the Amount (in current US$) of Sierra Leone in 1994 to that in 1997?
Provide a succinct answer. 1.67. What is the ratio of the Amount (in current US$) in Tonga in 1994 to that in 1997?
Your response must be concise. 2.67. What is the ratio of the Amount (in current US$) of Chad in 1994 to that in 1998?
Your answer should be compact. 0.92. What is the ratio of the Amount (in current US$) of Rwanda in 1994 to that in 1998?
Your response must be concise. 0.56. What is the ratio of the Amount (in current US$) in Sierra Leone in 1994 to that in 1998?
Your response must be concise. 3.76. What is the ratio of the Amount (in current US$) of Tonga in 1994 to that in 1998?
Provide a short and direct response. 1.08. What is the ratio of the Amount (in current US$) in Chad in 1994 to that in 1999?
Provide a short and direct response. 0.73. What is the ratio of the Amount (in current US$) of Rwanda in 1994 to that in 1999?
Provide a short and direct response. 0.88. What is the ratio of the Amount (in current US$) in Sierra Leone in 1994 to that in 1999?
Offer a very short reply. 7.16. What is the ratio of the Amount (in current US$) of Tonga in 1994 to that in 1999?
Offer a very short reply. 2.65. What is the ratio of the Amount (in current US$) of Chad in 1994 to that in 2000?
Offer a terse response. 1.82. What is the ratio of the Amount (in current US$) of Sierra Leone in 1994 to that in 2000?
Your answer should be very brief. 11.66. What is the ratio of the Amount (in current US$) in Tonga in 1994 to that in 2000?
Your answer should be compact. 2.02. What is the ratio of the Amount (in current US$) of Chad in 1994 to that in 2001?
Keep it short and to the point. 1.82. What is the ratio of the Amount (in current US$) in Rwanda in 1994 to that in 2001?
Offer a very short reply. 0.79. What is the ratio of the Amount (in current US$) of Sierra Leone in 1994 to that in 2001?
Provide a short and direct response. 1.31. What is the ratio of the Amount (in current US$) of Chad in 1995 to that in 1996?
Your answer should be compact. 0.54. What is the ratio of the Amount (in current US$) of Rwanda in 1995 to that in 1996?
Your response must be concise. 1.93. What is the ratio of the Amount (in current US$) in Sierra Leone in 1995 to that in 1996?
Make the answer very short. 1.34. What is the ratio of the Amount (in current US$) in Tonga in 1995 to that in 1996?
Provide a short and direct response. 2. What is the ratio of the Amount (in current US$) of Chad in 1995 to that in 1997?
Ensure brevity in your answer.  0.6. What is the ratio of the Amount (in current US$) in Rwanda in 1995 to that in 1997?
Your response must be concise. 1.77. What is the ratio of the Amount (in current US$) of Sierra Leone in 1995 to that in 1997?
Provide a short and direct response. 2.92. What is the ratio of the Amount (in current US$) of Tonga in 1995 to that in 1997?
Your response must be concise. 2.88. What is the ratio of the Amount (in current US$) in Chad in 1995 to that in 1998?
Your answer should be very brief. 0.68. What is the ratio of the Amount (in current US$) in Sierra Leone in 1995 to that in 1998?
Give a very brief answer. 6.58. What is the ratio of the Amount (in current US$) in Tonga in 1995 to that in 1998?
Make the answer very short. 1.17. What is the ratio of the Amount (in current US$) of Chad in 1995 to that in 1999?
Your answer should be very brief. 0.54. What is the ratio of the Amount (in current US$) of Rwanda in 1995 to that in 1999?
Make the answer very short. 1.53. What is the ratio of the Amount (in current US$) of Sierra Leone in 1995 to that in 1999?
Your answer should be compact. 12.55. What is the ratio of the Amount (in current US$) in Tonga in 1995 to that in 1999?
Ensure brevity in your answer.  2.86. What is the ratio of the Amount (in current US$) in Chad in 1995 to that in 2000?
Offer a very short reply. 1.35. What is the ratio of the Amount (in current US$) in Sierra Leone in 1995 to that in 2000?
Your response must be concise. 20.44. What is the ratio of the Amount (in current US$) of Tonga in 1995 to that in 2000?
Provide a succinct answer. 2.18. What is the ratio of the Amount (in current US$) of Chad in 1995 to that in 2001?
Your response must be concise. 1.35. What is the ratio of the Amount (in current US$) of Rwanda in 1995 to that in 2001?
Make the answer very short. 1.37. What is the ratio of the Amount (in current US$) in Sierra Leone in 1995 to that in 2001?
Your answer should be compact. 2.29. What is the ratio of the Amount (in current US$) of Chad in 1996 to that in 1997?
Offer a very short reply. 1.12. What is the ratio of the Amount (in current US$) of Rwanda in 1996 to that in 1997?
Offer a very short reply. 0.92. What is the ratio of the Amount (in current US$) of Sierra Leone in 1996 to that in 1997?
Give a very brief answer. 2.18. What is the ratio of the Amount (in current US$) of Tonga in 1996 to that in 1997?
Offer a very short reply. 1.44. What is the ratio of the Amount (in current US$) of Chad in 1996 to that in 1998?
Keep it short and to the point. 1.27. What is the ratio of the Amount (in current US$) in Rwanda in 1996 to that in 1998?
Offer a terse response. 0.51. What is the ratio of the Amount (in current US$) of Sierra Leone in 1996 to that in 1998?
Ensure brevity in your answer.  4.9. What is the ratio of the Amount (in current US$) in Tonga in 1996 to that in 1998?
Offer a terse response. 0.58. What is the ratio of the Amount (in current US$) in Rwanda in 1996 to that in 1999?
Provide a succinct answer. 0.79. What is the ratio of the Amount (in current US$) of Sierra Leone in 1996 to that in 1999?
Ensure brevity in your answer.  9.34. What is the ratio of the Amount (in current US$) in Tonga in 1996 to that in 1999?
Offer a very short reply. 1.43. What is the ratio of the Amount (in current US$) of Chad in 1996 to that in 2000?
Your answer should be very brief. 2.51. What is the ratio of the Amount (in current US$) in Sierra Leone in 1996 to that in 2000?
Give a very brief answer. 15.21. What is the ratio of the Amount (in current US$) in Tonga in 1996 to that in 2000?
Make the answer very short. 1.09. What is the ratio of the Amount (in current US$) of Chad in 1996 to that in 2001?
Offer a terse response. 2.51. What is the ratio of the Amount (in current US$) of Rwanda in 1996 to that in 2001?
Keep it short and to the point. 0.71. What is the ratio of the Amount (in current US$) of Sierra Leone in 1996 to that in 2001?
Provide a succinct answer. 1.71. What is the ratio of the Amount (in current US$) of Chad in 1997 to that in 1998?
Provide a short and direct response. 1.14. What is the ratio of the Amount (in current US$) of Rwanda in 1997 to that in 1998?
Keep it short and to the point. 0.55. What is the ratio of the Amount (in current US$) in Sierra Leone in 1997 to that in 1998?
Provide a succinct answer. 2.25. What is the ratio of the Amount (in current US$) in Tonga in 1997 to that in 1998?
Make the answer very short. 0.4. What is the ratio of the Amount (in current US$) in Chad in 1997 to that in 1999?
Offer a terse response. 0.89. What is the ratio of the Amount (in current US$) in Rwanda in 1997 to that in 1999?
Keep it short and to the point. 0.86. What is the ratio of the Amount (in current US$) in Sierra Leone in 1997 to that in 1999?
Your response must be concise. 4.29. What is the ratio of the Amount (in current US$) of Chad in 1997 to that in 2000?
Your response must be concise. 2.24. What is the ratio of the Amount (in current US$) in Sierra Leone in 1997 to that in 2000?
Provide a short and direct response. 6.99. What is the ratio of the Amount (in current US$) in Tonga in 1997 to that in 2000?
Provide a short and direct response. 0.76. What is the ratio of the Amount (in current US$) of Chad in 1997 to that in 2001?
Offer a terse response. 2.25. What is the ratio of the Amount (in current US$) in Rwanda in 1997 to that in 2001?
Offer a very short reply. 0.77. What is the ratio of the Amount (in current US$) in Sierra Leone in 1997 to that in 2001?
Keep it short and to the point. 0.78. What is the ratio of the Amount (in current US$) of Chad in 1998 to that in 1999?
Offer a very short reply. 0.79. What is the ratio of the Amount (in current US$) in Rwanda in 1998 to that in 1999?
Provide a short and direct response. 1.56. What is the ratio of the Amount (in current US$) in Sierra Leone in 1998 to that in 1999?
Make the answer very short. 1.91. What is the ratio of the Amount (in current US$) in Tonga in 1998 to that in 1999?
Ensure brevity in your answer.  2.45. What is the ratio of the Amount (in current US$) in Chad in 1998 to that in 2000?
Provide a short and direct response. 1.98. What is the ratio of the Amount (in current US$) in Sierra Leone in 1998 to that in 2000?
Offer a very short reply. 3.1. What is the ratio of the Amount (in current US$) in Tonga in 1998 to that in 2000?
Your response must be concise. 1.87. What is the ratio of the Amount (in current US$) of Chad in 1998 to that in 2001?
Your response must be concise. 1.98. What is the ratio of the Amount (in current US$) of Rwanda in 1998 to that in 2001?
Make the answer very short. 1.4. What is the ratio of the Amount (in current US$) of Sierra Leone in 1998 to that in 2001?
Give a very brief answer. 0.35. What is the ratio of the Amount (in current US$) in Chad in 1999 to that in 2000?
Ensure brevity in your answer.  2.51. What is the ratio of the Amount (in current US$) in Sierra Leone in 1999 to that in 2000?
Give a very brief answer. 1.63. What is the ratio of the Amount (in current US$) of Tonga in 1999 to that in 2000?
Ensure brevity in your answer.  0.76. What is the ratio of the Amount (in current US$) in Chad in 1999 to that in 2001?
Make the answer very short. 2.51. What is the ratio of the Amount (in current US$) in Rwanda in 1999 to that in 2001?
Ensure brevity in your answer.  0.9. What is the ratio of the Amount (in current US$) in Sierra Leone in 1999 to that in 2001?
Your answer should be very brief. 0.18. What is the ratio of the Amount (in current US$) in Chad in 2000 to that in 2001?
Make the answer very short. 1. What is the ratio of the Amount (in current US$) in Sierra Leone in 2000 to that in 2001?
Provide a succinct answer. 0.11. What is the difference between the highest and the second highest Amount (in current US$) in Chad?
Ensure brevity in your answer.  3.50e+04. What is the difference between the highest and the second highest Amount (in current US$) in Sierra Leone?
Keep it short and to the point. 7.25e+06. What is the difference between the highest and the second highest Amount (in current US$) of Tonga?
Offer a terse response. 3.90e+05. What is the difference between the highest and the lowest Amount (in current US$) of Chad?
Your answer should be very brief. 1.42e+07. What is the difference between the highest and the lowest Amount (in current US$) of Rwanda?
Give a very brief answer. 1.42e+07. What is the difference between the highest and the lowest Amount (in current US$) in Sierra Leone?
Provide a succinct answer. 2.70e+07. What is the difference between the highest and the lowest Amount (in current US$) in Tonga?
Your answer should be compact. 5.35e+06. 